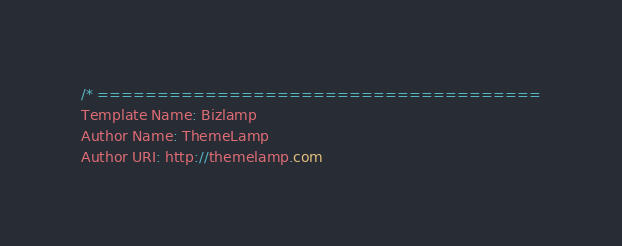Convert code to text. <code><loc_0><loc_0><loc_500><loc_500><_CSS_>/* =====================================
Template Name: Bizlamp
Author Name: ThemeLamp
Author URI: http://themelamp.com</code> 